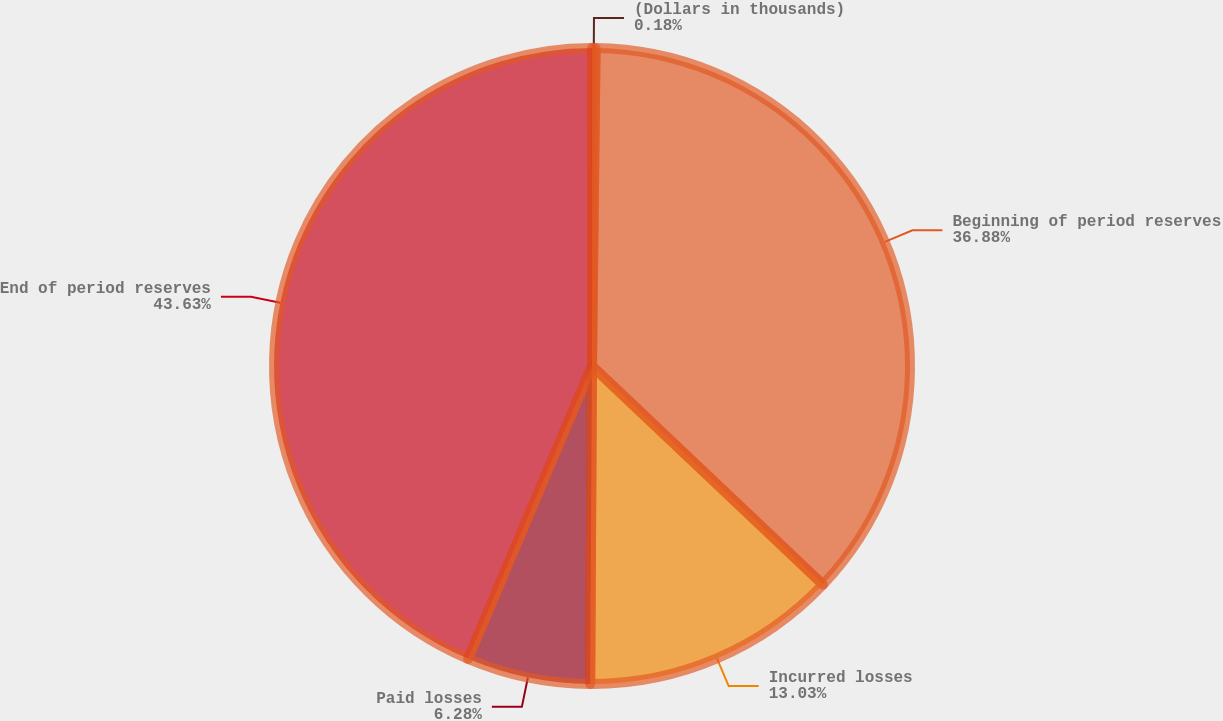Convert chart to OTSL. <chart><loc_0><loc_0><loc_500><loc_500><pie_chart><fcel>(Dollars in thousands)<fcel>Beginning of period reserves<fcel>Incurred losses<fcel>Paid losses<fcel>End of period reserves<nl><fcel>0.18%<fcel>36.88%<fcel>13.03%<fcel>6.28%<fcel>43.63%<nl></chart> 